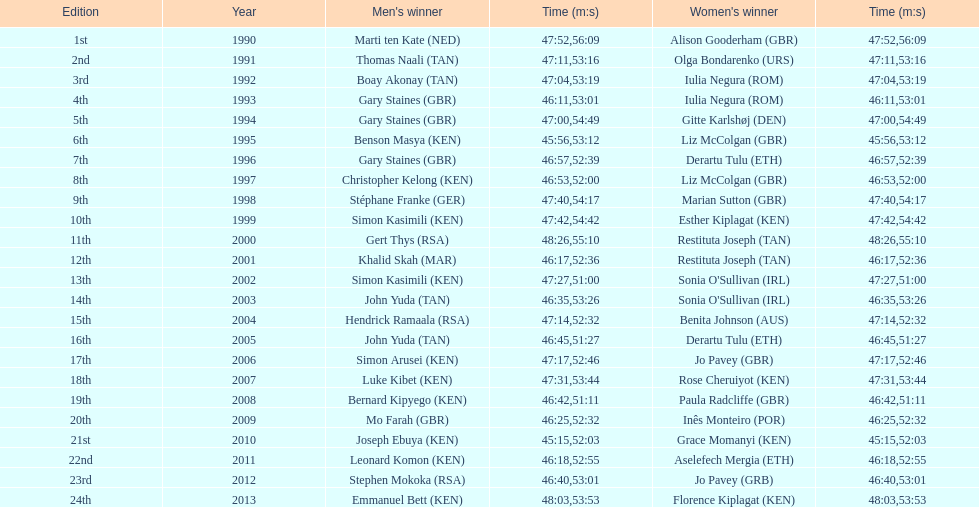What is the title of the initial female victor? Alison Gooderham. 